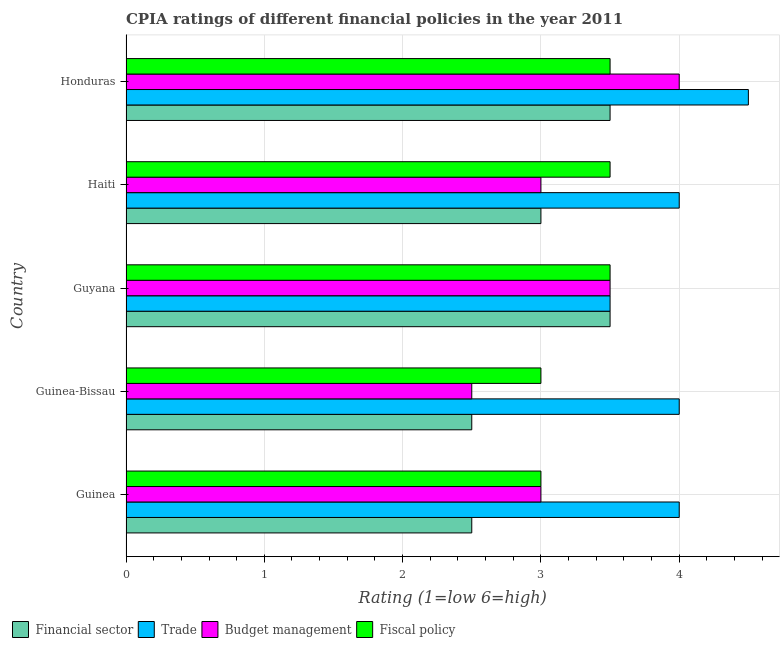How many different coloured bars are there?
Make the answer very short. 4. How many groups of bars are there?
Provide a short and direct response. 5. How many bars are there on the 4th tick from the top?
Make the answer very short. 4. What is the label of the 1st group of bars from the top?
Ensure brevity in your answer.  Honduras. What is the cpia rating of financial sector in Guyana?
Your answer should be very brief. 3.5. Across all countries, what is the maximum cpia rating of trade?
Your response must be concise. 4.5. In which country was the cpia rating of financial sector maximum?
Your response must be concise. Guyana. In which country was the cpia rating of budget management minimum?
Provide a succinct answer. Guinea-Bissau. What is the difference between the cpia rating of trade in Guinea and that in Honduras?
Keep it short and to the point. -0.5. What is the average cpia rating of fiscal policy per country?
Offer a terse response. 3.3. In how many countries, is the cpia rating of financial sector greater than 3 ?
Your answer should be very brief. 2. What is the ratio of the cpia rating of fiscal policy in Guinea to that in Honduras?
Provide a succinct answer. 0.86. Is the cpia rating of financial sector in Guinea-Bissau less than that in Guyana?
Provide a succinct answer. Yes. Is the difference between the cpia rating of trade in Guinea-Bissau and Haiti greater than the difference between the cpia rating of financial sector in Guinea-Bissau and Haiti?
Your response must be concise. Yes. Is it the case that in every country, the sum of the cpia rating of fiscal policy and cpia rating of budget management is greater than the sum of cpia rating of financial sector and cpia rating of trade?
Give a very brief answer. No. What does the 3rd bar from the top in Guinea-Bissau represents?
Offer a very short reply. Trade. What does the 2nd bar from the bottom in Guinea represents?
Provide a short and direct response. Trade. Is it the case that in every country, the sum of the cpia rating of financial sector and cpia rating of trade is greater than the cpia rating of budget management?
Provide a short and direct response. Yes. Are all the bars in the graph horizontal?
Ensure brevity in your answer.  Yes. How many countries are there in the graph?
Offer a terse response. 5. Does the graph contain grids?
Offer a very short reply. Yes. How are the legend labels stacked?
Offer a terse response. Horizontal. What is the title of the graph?
Your response must be concise. CPIA ratings of different financial policies in the year 2011. Does "Japan" appear as one of the legend labels in the graph?
Make the answer very short. No. What is the label or title of the Y-axis?
Give a very brief answer. Country. What is the Rating (1=low 6=high) in Financial sector in Guinea?
Your answer should be compact. 2.5. What is the Rating (1=low 6=high) in Budget management in Guinea?
Give a very brief answer. 3. What is the Rating (1=low 6=high) in Fiscal policy in Guinea?
Provide a succinct answer. 3. What is the Rating (1=low 6=high) in Budget management in Guinea-Bissau?
Offer a very short reply. 2.5. What is the Rating (1=low 6=high) in Budget management in Guyana?
Provide a short and direct response. 3.5. What is the Rating (1=low 6=high) in Trade in Haiti?
Your answer should be compact. 4. What is the Rating (1=low 6=high) in Budget management in Honduras?
Provide a short and direct response. 4. What is the Rating (1=low 6=high) in Fiscal policy in Honduras?
Your answer should be very brief. 3.5. Across all countries, what is the maximum Rating (1=low 6=high) of Financial sector?
Provide a succinct answer. 3.5. Across all countries, what is the maximum Rating (1=low 6=high) in Trade?
Make the answer very short. 4.5. Across all countries, what is the maximum Rating (1=low 6=high) of Fiscal policy?
Provide a succinct answer. 3.5. Across all countries, what is the minimum Rating (1=low 6=high) in Financial sector?
Provide a short and direct response. 2.5. Across all countries, what is the minimum Rating (1=low 6=high) of Trade?
Offer a terse response. 3.5. What is the total Rating (1=low 6=high) in Financial sector in the graph?
Make the answer very short. 15. What is the total Rating (1=low 6=high) in Trade in the graph?
Offer a very short reply. 20. What is the total Rating (1=low 6=high) in Budget management in the graph?
Ensure brevity in your answer.  16. What is the total Rating (1=low 6=high) in Fiscal policy in the graph?
Offer a very short reply. 16.5. What is the difference between the Rating (1=low 6=high) in Trade in Guinea and that in Guinea-Bissau?
Your answer should be very brief. 0. What is the difference between the Rating (1=low 6=high) of Trade in Guinea and that in Guyana?
Offer a terse response. 0.5. What is the difference between the Rating (1=low 6=high) of Budget management in Guinea and that in Guyana?
Your answer should be compact. -0.5. What is the difference between the Rating (1=low 6=high) of Financial sector in Guinea and that in Haiti?
Give a very brief answer. -0.5. What is the difference between the Rating (1=low 6=high) of Budget management in Guinea and that in Haiti?
Keep it short and to the point. 0. What is the difference between the Rating (1=low 6=high) in Financial sector in Guinea and that in Honduras?
Keep it short and to the point. -1. What is the difference between the Rating (1=low 6=high) of Trade in Guinea and that in Honduras?
Offer a terse response. -0.5. What is the difference between the Rating (1=low 6=high) of Budget management in Guinea and that in Honduras?
Your response must be concise. -1. What is the difference between the Rating (1=low 6=high) of Financial sector in Guinea-Bissau and that in Guyana?
Offer a very short reply. -1. What is the difference between the Rating (1=low 6=high) of Trade in Guinea-Bissau and that in Guyana?
Your answer should be very brief. 0.5. What is the difference between the Rating (1=low 6=high) in Budget management in Guinea-Bissau and that in Guyana?
Your answer should be very brief. -1. What is the difference between the Rating (1=low 6=high) in Fiscal policy in Guinea-Bissau and that in Guyana?
Ensure brevity in your answer.  -0.5. What is the difference between the Rating (1=low 6=high) in Financial sector in Guinea-Bissau and that in Haiti?
Provide a succinct answer. -0.5. What is the difference between the Rating (1=low 6=high) of Budget management in Guinea-Bissau and that in Haiti?
Your answer should be very brief. -0.5. What is the difference between the Rating (1=low 6=high) of Financial sector in Guinea-Bissau and that in Honduras?
Your response must be concise. -1. What is the difference between the Rating (1=low 6=high) in Trade in Guinea-Bissau and that in Honduras?
Offer a very short reply. -0.5. What is the difference between the Rating (1=low 6=high) in Budget management in Guinea-Bissau and that in Honduras?
Your response must be concise. -1.5. What is the difference between the Rating (1=low 6=high) of Fiscal policy in Guinea-Bissau and that in Honduras?
Ensure brevity in your answer.  -0.5. What is the difference between the Rating (1=low 6=high) in Financial sector in Guyana and that in Haiti?
Your answer should be very brief. 0.5. What is the difference between the Rating (1=low 6=high) of Trade in Guyana and that in Haiti?
Your response must be concise. -0.5. What is the difference between the Rating (1=low 6=high) of Financial sector in Guyana and that in Honduras?
Offer a very short reply. 0. What is the difference between the Rating (1=low 6=high) of Fiscal policy in Guyana and that in Honduras?
Provide a short and direct response. 0. What is the difference between the Rating (1=low 6=high) in Financial sector in Haiti and that in Honduras?
Your answer should be compact. -0.5. What is the difference between the Rating (1=low 6=high) in Financial sector in Guinea and the Rating (1=low 6=high) in Trade in Guinea-Bissau?
Provide a short and direct response. -1.5. What is the difference between the Rating (1=low 6=high) in Trade in Guinea and the Rating (1=low 6=high) in Budget management in Guinea-Bissau?
Your answer should be very brief. 1.5. What is the difference between the Rating (1=low 6=high) of Trade in Guinea and the Rating (1=low 6=high) of Fiscal policy in Guinea-Bissau?
Keep it short and to the point. 1. What is the difference between the Rating (1=low 6=high) in Budget management in Guinea and the Rating (1=low 6=high) in Fiscal policy in Guinea-Bissau?
Ensure brevity in your answer.  0. What is the difference between the Rating (1=low 6=high) in Trade in Guinea and the Rating (1=low 6=high) in Budget management in Guyana?
Provide a succinct answer. 0.5. What is the difference between the Rating (1=low 6=high) in Trade in Guinea and the Rating (1=low 6=high) in Budget management in Haiti?
Your answer should be very brief. 1. What is the difference between the Rating (1=low 6=high) of Trade in Guinea and the Rating (1=low 6=high) of Fiscal policy in Haiti?
Give a very brief answer. 0.5. What is the difference between the Rating (1=low 6=high) of Budget management in Guinea and the Rating (1=low 6=high) of Fiscal policy in Haiti?
Your answer should be very brief. -0.5. What is the difference between the Rating (1=low 6=high) in Financial sector in Guinea and the Rating (1=low 6=high) in Trade in Honduras?
Make the answer very short. -2. What is the difference between the Rating (1=low 6=high) of Financial sector in Guinea and the Rating (1=low 6=high) of Budget management in Honduras?
Keep it short and to the point. -1.5. What is the difference between the Rating (1=low 6=high) of Trade in Guinea and the Rating (1=low 6=high) of Fiscal policy in Honduras?
Offer a very short reply. 0.5. What is the difference between the Rating (1=low 6=high) of Financial sector in Guinea-Bissau and the Rating (1=low 6=high) of Fiscal policy in Guyana?
Ensure brevity in your answer.  -1. What is the difference between the Rating (1=low 6=high) in Trade in Guinea-Bissau and the Rating (1=low 6=high) in Fiscal policy in Guyana?
Offer a terse response. 0.5. What is the difference between the Rating (1=low 6=high) in Budget management in Guinea-Bissau and the Rating (1=low 6=high) in Fiscal policy in Guyana?
Keep it short and to the point. -1. What is the difference between the Rating (1=low 6=high) in Financial sector in Guinea-Bissau and the Rating (1=low 6=high) in Budget management in Haiti?
Ensure brevity in your answer.  -0.5. What is the difference between the Rating (1=low 6=high) of Trade in Guinea-Bissau and the Rating (1=low 6=high) of Budget management in Haiti?
Ensure brevity in your answer.  1. What is the difference between the Rating (1=low 6=high) in Financial sector in Guinea-Bissau and the Rating (1=low 6=high) in Trade in Honduras?
Your response must be concise. -2. What is the difference between the Rating (1=low 6=high) in Financial sector in Guinea-Bissau and the Rating (1=low 6=high) in Fiscal policy in Honduras?
Provide a short and direct response. -1. What is the difference between the Rating (1=low 6=high) in Budget management in Guinea-Bissau and the Rating (1=low 6=high) in Fiscal policy in Honduras?
Offer a very short reply. -1. What is the difference between the Rating (1=low 6=high) in Financial sector in Guyana and the Rating (1=low 6=high) in Budget management in Haiti?
Provide a succinct answer. 0.5. What is the difference between the Rating (1=low 6=high) in Financial sector in Guyana and the Rating (1=low 6=high) in Fiscal policy in Haiti?
Make the answer very short. 0. What is the difference between the Rating (1=low 6=high) in Trade in Guyana and the Rating (1=low 6=high) in Budget management in Haiti?
Provide a short and direct response. 0.5. What is the difference between the Rating (1=low 6=high) of Budget management in Guyana and the Rating (1=low 6=high) of Fiscal policy in Haiti?
Provide a succinct answer. 0. What is the difference between the Rating (1=low 6=high) of Financial sector in Guyana and the Rating (1=low 6=high) of Trade in Honduras?
Provide a short and direct response. -1. What is the difference between the Rating (1=low 6=high) of Budget management in Guyana and the Rating (1=low 6=high) of Fiscal policy in Honduras?
Your answer should be compact. 0. What is the difference between the Rating (1=low 6=high) in Financial sector in Haiti and the Rating (1=low 6=high) in Fiscal policy in Honduras?
Provide a succinct answer. -0.5. What is the difference between the Rating (1=low 6=high) in Trade in Haiti and the Rating (1=low 6=high) in Fiscal policy in Honduras?
Offer a very short reply. 0.5. What is the average Rating (1=low 6=high) of Financial sector per country?
Your answer should be compact. 3. What is the average Rating (1=low 6=high) of Trade per country?
Keep it short and to the point. 4. What is the average Rating (1=low 6=high) of Budget management per country?
Ensure brevity in your answer.  3.2. What is the average Rating (1=low 6=high) in Fiscal policy per country?
Provide a succinct answer. 3.3. What is the difference between the Rating (1=low 6=high) in Financial sector and Rating (1=low 6=high) in Budget management in Guinea?
Your answer should be compact. -0.5. What is the difference between the Rating (1=low 6=high) in Trade and Rating (1=low 6=high) in Budget management in Guinea?
Provide a short and direct response. 1. What is the difference between the Rating (1=low 6=high) in Trade and Rating (1=low 6=high) in Fiscal policy in Guinea?
Your answer should be compact. 1. What is the difference between the Rating (1=low 6=high) in Trade and Rating (1=low 6=high) in Fiscal policy in Guinea-Bissau?
Your response must be concise. 1. What is the difference between the Rating (1=low 6=high) of Budget management and Rating (1=low 6=high) of Fiscal policy in Guinea-Bissau?
Make the answer very short. -0.5. What is the difference between the Rating (1=low 6=high) in Financial sector and Rating (1=low 6=high) in Trade in Guyana?
Keep it short and to the point. 0. What is the difference between the Rating (1=low 6=high) in Financial sector and Rating (1=low 6=high) in Budget management in Guyana?
Provide a short and direct response. 0. What is the difference between the Rating (1=low 6=high) in Trade and Rating (1=low 6=high) in Budget management in Guyana?
Keep it short and to the point. 0. What is the difference between the Rating (1=low 6=high) in Trade and Rating (1=low 6=high) in Fiscal policy in Guyana?
Your answer should be compact. 0. What is the difference between the Rating (1=low 6=high) in Financial sector and Rating (1=low 6=high) in Budget management in Haiti?
Your response must be concise. 0. What is the difference between the Rating (1=low 6=high) of Trade and Rating (1=low 6=high) of Budget management in Haiti?
Offer a terse response. 1. What is the difference between the Rating (1=low 6=high) in Trade and Rating (1=low 6=high) in Budget management in Honduras?
Your answer should be compact. 0.5. What is the difference between the Rating (1=low 6=high) of Budget management and Rating (1=low 6=high) of Fiscal policy in Honduras?
Your answer should be very brief. 0.5. What is the ratio of the Rating (1=low 6=high) in Financial sector in Guinea to that in Guyana?
Offer a terse response. 0.71. What is the ratio of the Rating (1=low 6=high) in Financial sector in Guinea to that in Honduras?
Give a very brief answer. 0.71. What is the ratio of the Rating (1=low 6=high) of Budget management in Guinea to that in Honduras?
Keep it short and to the point. 0.75. What is the ratio of the Rating (1=low 6=high) of Fiscal policy in Guinea to that in Honduras?
Give a very brief answer. 0.86. What is the ratio of the Rating (1=low 6=high) of Trade in Guinea-Bissau to that in Guyana?
Make the answer very short. 1.14. What is the ratio of the Rating (1=low 6=high) of Budget management in Guinea-Bissau to that in Guyana?
Offer a very short reply. 0.71. What is the ratio of the Rating (1=low 6=high) of Financial sector in Guinea-Bissau to that in Haiti?
Ensure brevity in your answer.  0.83. What is the ratio of the Rating (1=low 6=high) in Trade in Guinea-Bissau to that in Haiti?
Make the answer very short. 1. What is the ratio of the Rating (1=low 6=high) of Budget management in Guinea-Bissau to that in Haiti?
Provide a succinct answer. 0.83. What is the ratio of the Rating (1=low 6=high) of Fiscal policy in Guinea-Bissau to that in Haiti?
Your answer should be compact. 0.86. What is the ratio of the Rating (1=low 6=high) in Budget management in Guinea-Bissau to that in Honduras?
Provide a succinct answer. 0.62. What is the ratio of the Rating (1=low 6=high) of Financial sector in Guyana to that in Haiti?
Make the answer very short. 1.17. What is the ratio of the Rating (1=low 6=high) of Trade in Guyana to that in Haiti?
Make the answer very short. 0.88. What is the ratio of the Rating (1=low 6=high) of Budget management in Guyana to that in Haiti?
Provide a short and direct response. 1.17. What is the ratio of the Rating (1=low 6=high) in Trade in Guyana to that in Honduras?
Your response must be concise. 0.78. What is the ratio of the Rating (1=low 6=high) in Financial sector in Haiti to that in Honduras?
Make the answer very short. 0.86. What is the ratio of the Rating (1=low 6=high) of Trade in Haiti to that in Honduras?
Ensure brevity in your answer.  0.89. What is the ratio of the Rating (1=low 6=high) in Budget management in Haiti to that in Honduras?
Make the answer very short. 0.75. What is the difference between the highest and the second highest Rating (1=low 6=high) of Financial sector?
Provide a succinct answer. 0. 